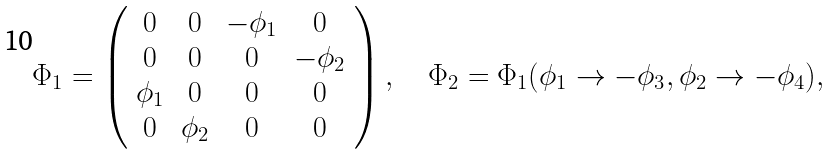Convert formula to latex. <formula><loc_0><loc_0><loc_500><loc_500>\Phi _ { 1 } = \left ( \begin{array} { c c c c } 0 & 0 & - \phi _ { 1 } & 0 \\ 0 & 0 & 0 & - \phi _ { 2 } \\ \phi _ { 1 } & 0 & 0 & 0 \\ 0 & \phi _ { 2 } & 0 & 0 \end{array} \right ) , \quad \Phi _ { 2 } = \Phi _ { 1 } ( \phi _ { 1 } \to - \phi _ { 3 } , \phi _ { 2 } \to - \phi _ { 4 } ) ,</formula> 